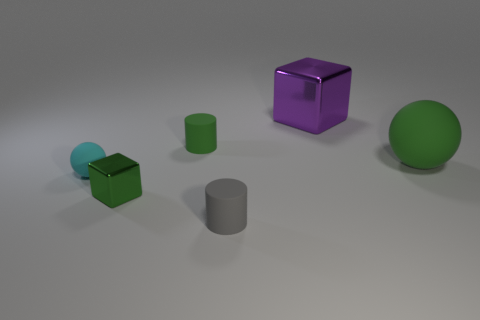Add 2 gray things. How many objects exist? 8 Subtract all purple blocks. How many blocks are left? 1 Subtract 1 cylinders. How many cylinders are left? 1 Add 3 green rubber cylinders. How many green rubber cylinders are left? 4 Add 5 big purple metallic cylinders. How many big purple metallic cylinders exist? 5 Subtract 0 yellow spheres. How many objects are left? 6 Subtract all cyan blocks. Subtract all gray cylinders. How many blocks are left? 2 Subtract all large green objects. Subtract all large blue metal blocks. How many objects are left? 5 